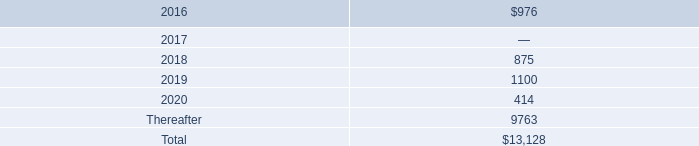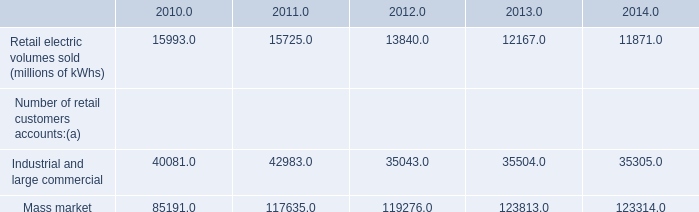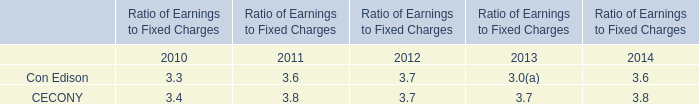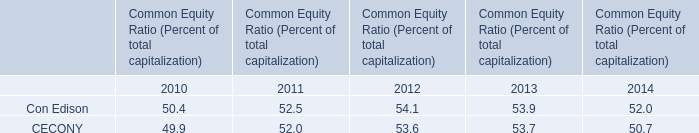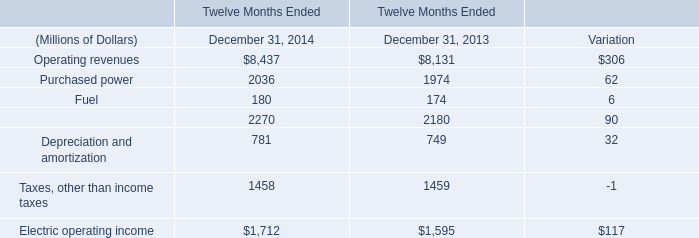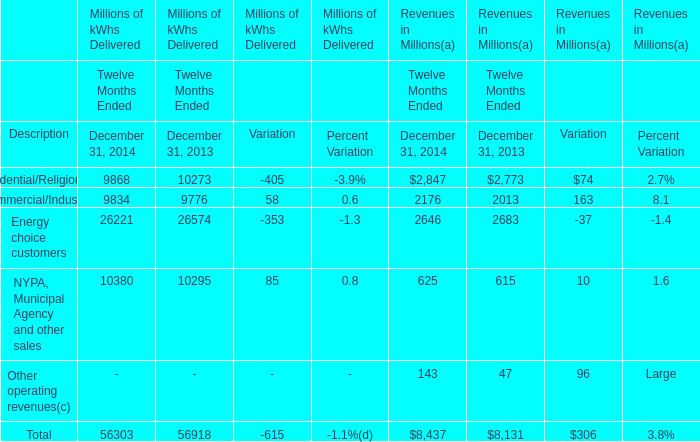If Purchased power develops with the same increasing rate in 2014, what will it reach in 2015? (in millions) 
Computations: ((1 + ((2036 - 1974) / 1974)) * 2036)
Answer: 2099.94732. 